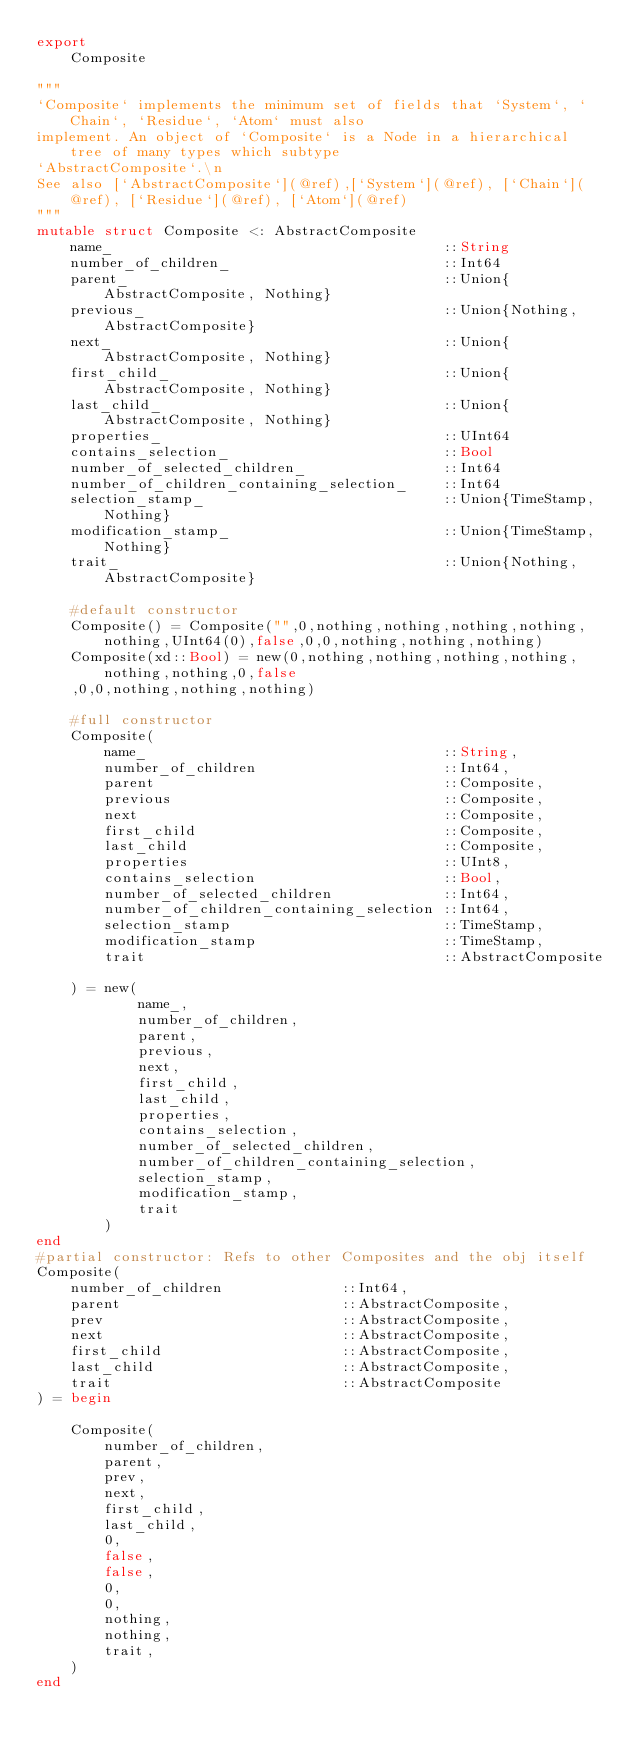<code> <loc_0><loc_0><loc_500><loc_500><_Julia_>export
    Composite

"""
`Composite` implements the minimum set of fields that `System`, `Chain`, `Residue`, `Atom` must also
implement. An object of `Composite` is a Node in a hierarchical tree of many types which subtype
`AbstractComposite`.\n
See also [`AbstractComposite`](@ref),[`System`](@ref), [`Chain`](@ref), [`Residue`](@ref), [`Atom`](@ref)
"""
mutable struct Composite <: AbstractComposite
    name_                                       ::String
    number_of_children_                         ::Int64
    parent_                                     ::Union{AbstractComposite, Nothing}
    previous_                                   ::Union{Nothing, AbstractComposite}
    next_                                       ::Union{AbstractComposite, Nothing}
    first_child_                                ::Union{AbstractComposite, Nothing}
    last_child_                                 ::Union{AbstractComposite, Nothing}
    properties_                                 ::UInt64
    contains_selection_                         ::Bool
    number_of_selected_children_                ::Int64
    number_of_children_containing_selection_    ::Int64
    selection_stamp_                            ::Union{TimeStamp,Nothing}
    modification_stamp_                         ::Union{TimeStamp,Nothing}
    trait_                                      ::Union{Nothing,AbstractComposite}

    #default constructor
    Composite() = Composite("",0,nothing,nothing,nothing,nothing,nothing,UInt64(0),false,0,0,nothing,nothing,nothing)
    Composite(xd::Bool) = new(0,nothing,nothing,nothing,nothing,nothing,nothing,0,false
    ,0,0,nothing,nothing,nothing)

    #full constructor
    Composite(
        name_                                   ::String,
        number_of_children                      ::Int64,
        parent                                  ::Composite,
        previous                                ::Composite,
        next                                    ::Composite,
        first_child                             ::Composite,
        last_child                              ::Composite,
        properties                              ::UInt8,
        contains_selection                      ::Bool,
        number_of_selected_children             ::Int64,
        number_of_children_containing_selection ::Int64,
        selection_stamp                         ::TimeStamp,
        modification_stamp                      ::TimeStamp,
        trait                                   ::AbstractComposite

    ) = new(
            name_,
            number_of_children,
            parent,
            previous,
            next,
            first_child,
            last_child,
            properties,
            contains_selection,
            number_of_selected_children,
            number_of_children_containing_selection,
            selection_stamp,
            modification_stamp,
            trait
        )
end
#partial constructor: Refs to other Composites and the obj itself
Composite(
    number_of_children              ::Int64,
    parent                          ::AbstractComposite,
    prev                            ::AbstractComposite,
    next                            ::AbstractComposite,
    first_child                     ::AbstractComposite,
    last_child                      ::AbstractComposite,
    trait                           ::AbstractComposite
) = begin

    Composite(
        number_of_children,
        parent,
        prev,
        next,
        first_child,
        last_child,
        0,
        false,
        false,
        0,
        0,
        nothing,
        nothing,
        trait,
    )
end
</code> 